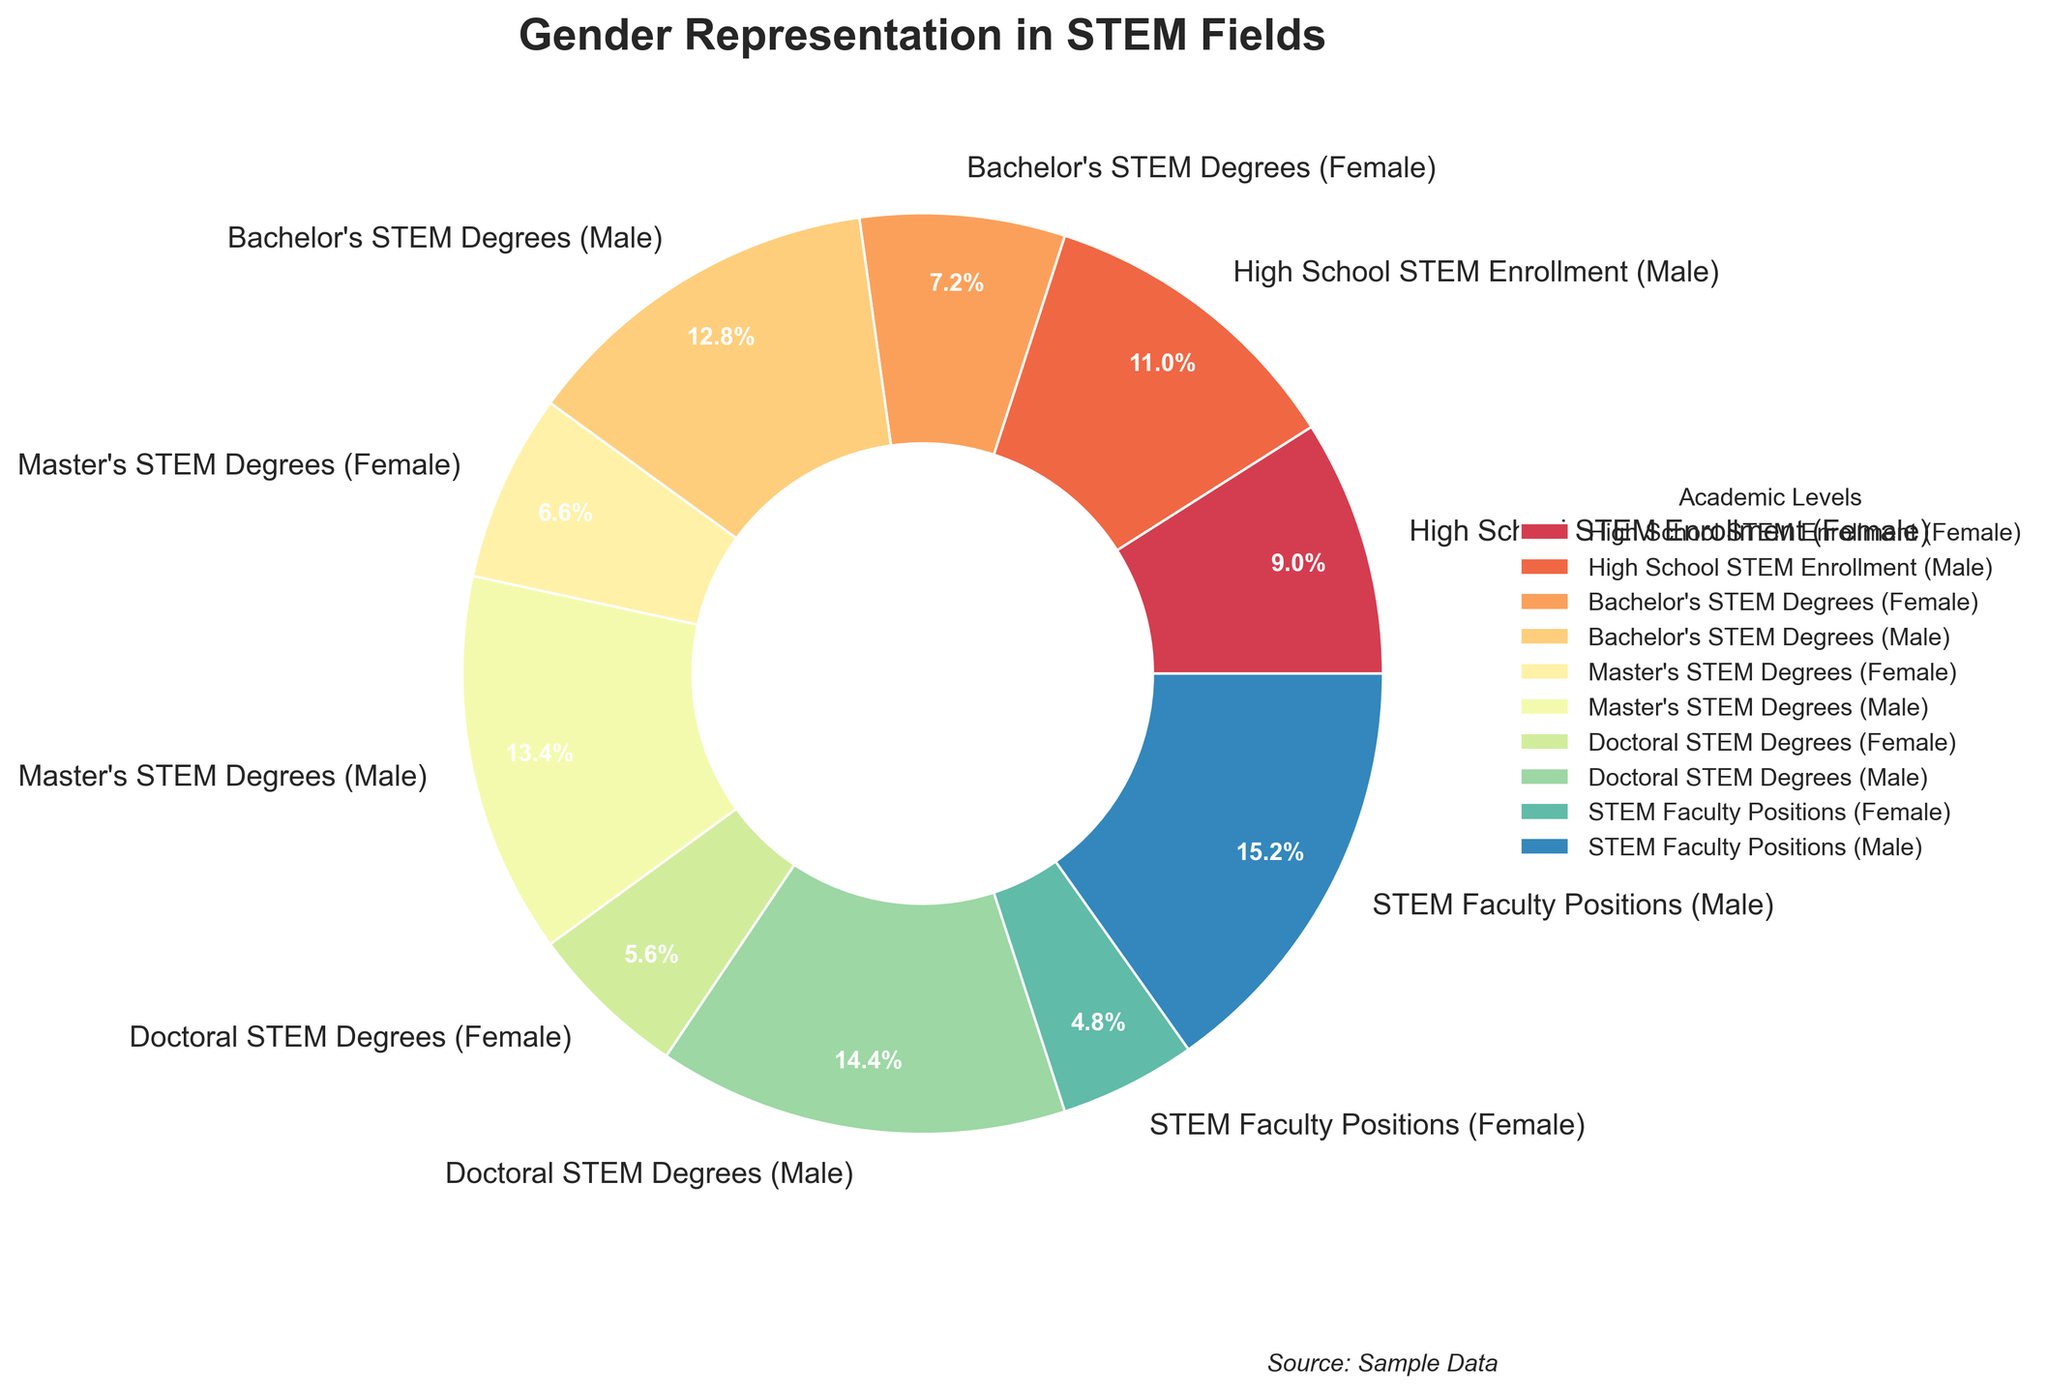What percentage of STEM faculty positions are held by females? On the pie chart, locate the section labeled "STEM Faculty Positions (Female)." The percentage indicated is 24%.
Answer: 24% Compare the percentage of females in Bachelor's STEM Degrees versus Doctoral STEM Degrees. Look at the "Bachelor's STEM Degrees (Female)" section which shows 36% and then "Doctoral STEM Degrees (Female)" which shows 28%. The percentage of females in Bachelor's STEM Degrees is higher.
Answer: Bachelor's 36%, Doctoral 28% Which academic level has the largest gender gap in representation? Examine all the segments and calculate the differences between male and female percentages. The largest gap is in "STEM Faculty Positions" with a gender gap of 76-24=52 percentage points.
Answer: STEM Faculty Positions What's the total percentage of females across all academic levels? Add up the female percentages: 45 (High School) + 36 (Bachelor's) + 33 (Master's) + 28 (Doctoral) + 24 (Faculty) = 166%. Then count the number of categories (5). The total is 166/5 = 33.2%.
Answer: 33.2% Are there more females or males enrolled in High School STEM programs? Compare the High School STEM enrollment percentages. Females have 45% and males have 55%. Males have a higher percentage.
Answer: Males What is the difference between the percentage of males in Master's STEM Degrees and in STEM Faculty Positions? Locate the "Master's STEM Degrees (Male)" section which is 67% and the "STEM Faculty Positions (Male)" section which is 76%. The difference is 76 - 67 = 9 percentage points.
Answer: 9% Which category shows the smallest percentage difference between males and females? Calculate the percentage differences for all categories and find the smallest: "High School STEM Enrollment" has a difference of 55-45=10 percentage points.
Answer: High School STEM Enrollment Compare the color of the section representing female Master's STEM Degrees with the section representing male Doctoral STEM Degrees. The sections "Master's STEM Degrees (Female)" and "Doctoral STEM Degrees (Male)" are represented by different shades. The specific color details are assigned based on a colormap, but these shades are distinct to indicate different data categories.
Answer: Distinct colors How much higher is the percentage of males in Doctoral STEM Degrees compared to females? Locate "Doctoral STEM Degrees" sections for both genders: Males are at 72% and females at 28%. The difference is 72 - 28 = 44 percentage points.
Answer: 44% What trend do you observe in gender representation as the academic level increases from High School to Faculty Positions? Analyze the percentages of females and males from High School to Faculty Positions. There is a decreasing trend in female representation and an increasing trend in male representation at higher academic levels.
Answer: Decreasing females, increasing males 